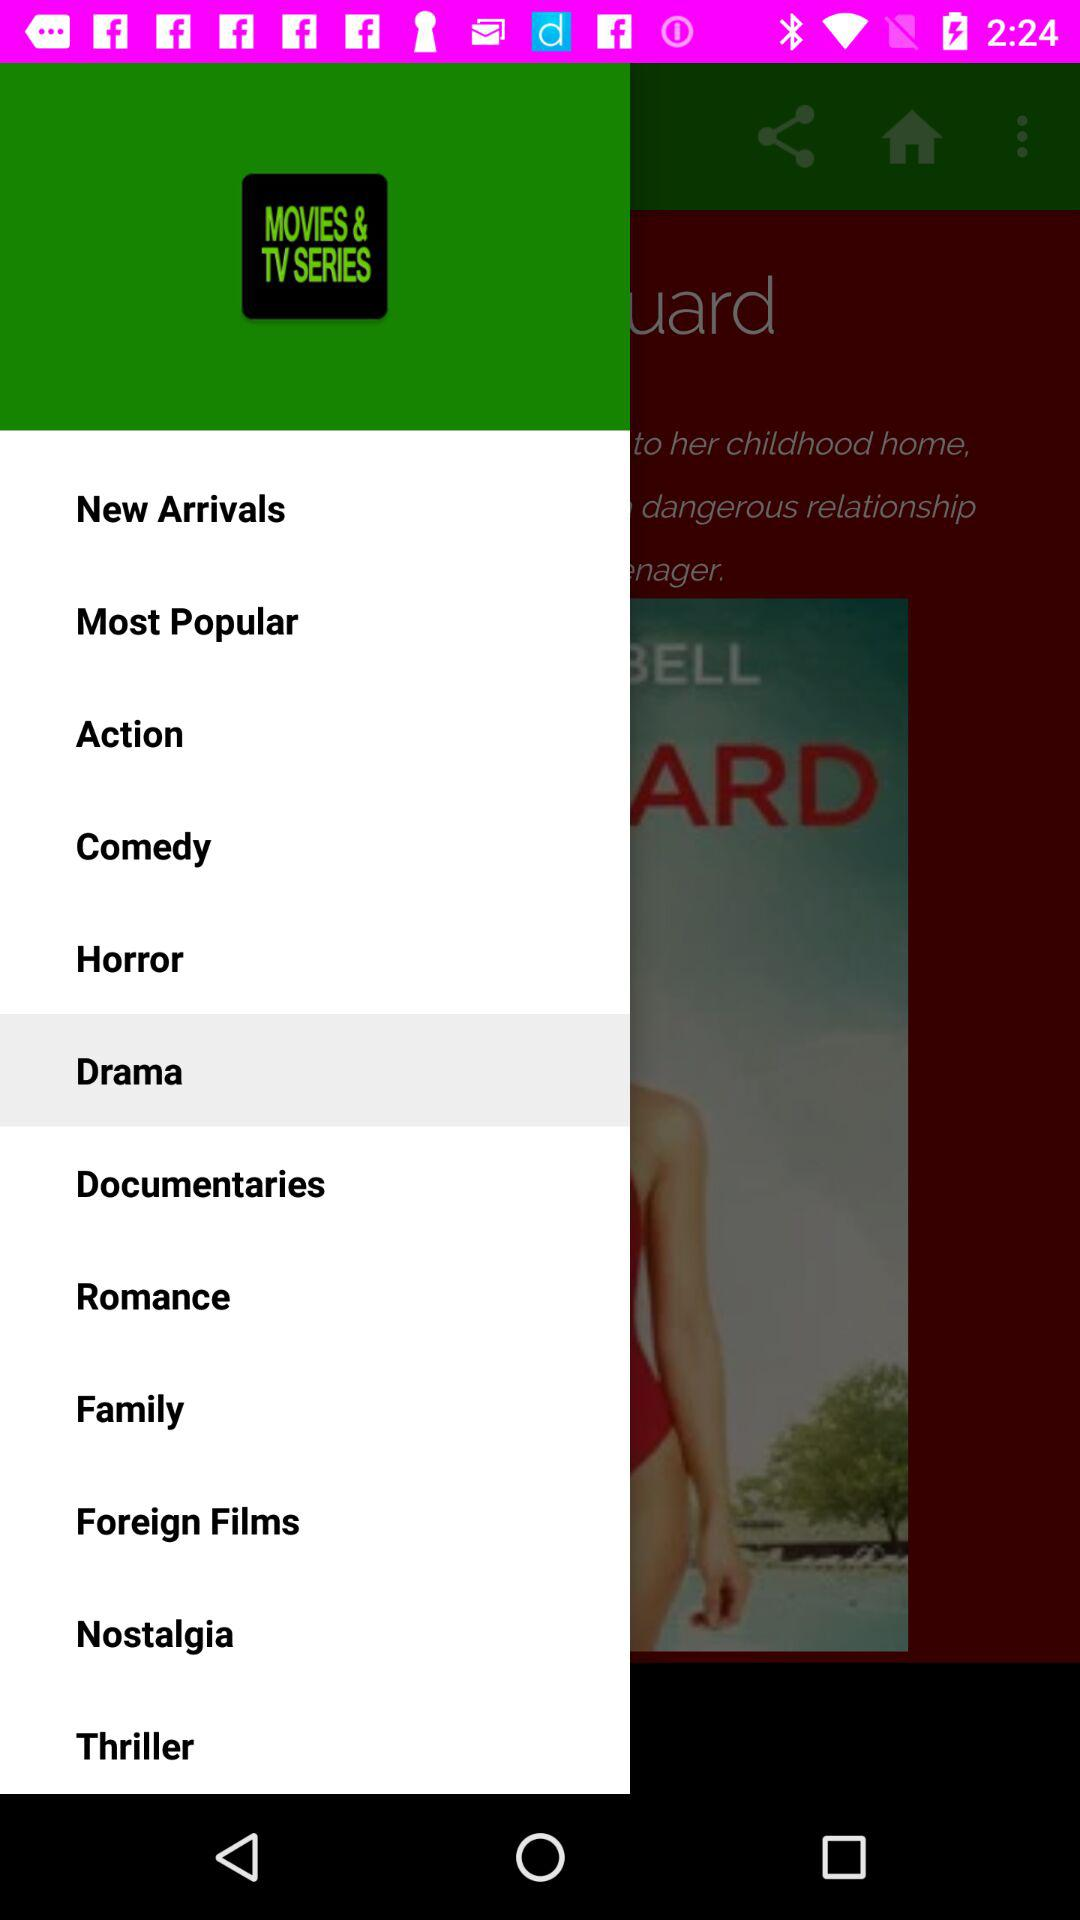What item is selected as a genre? The selected item as a genre is "Drama". 